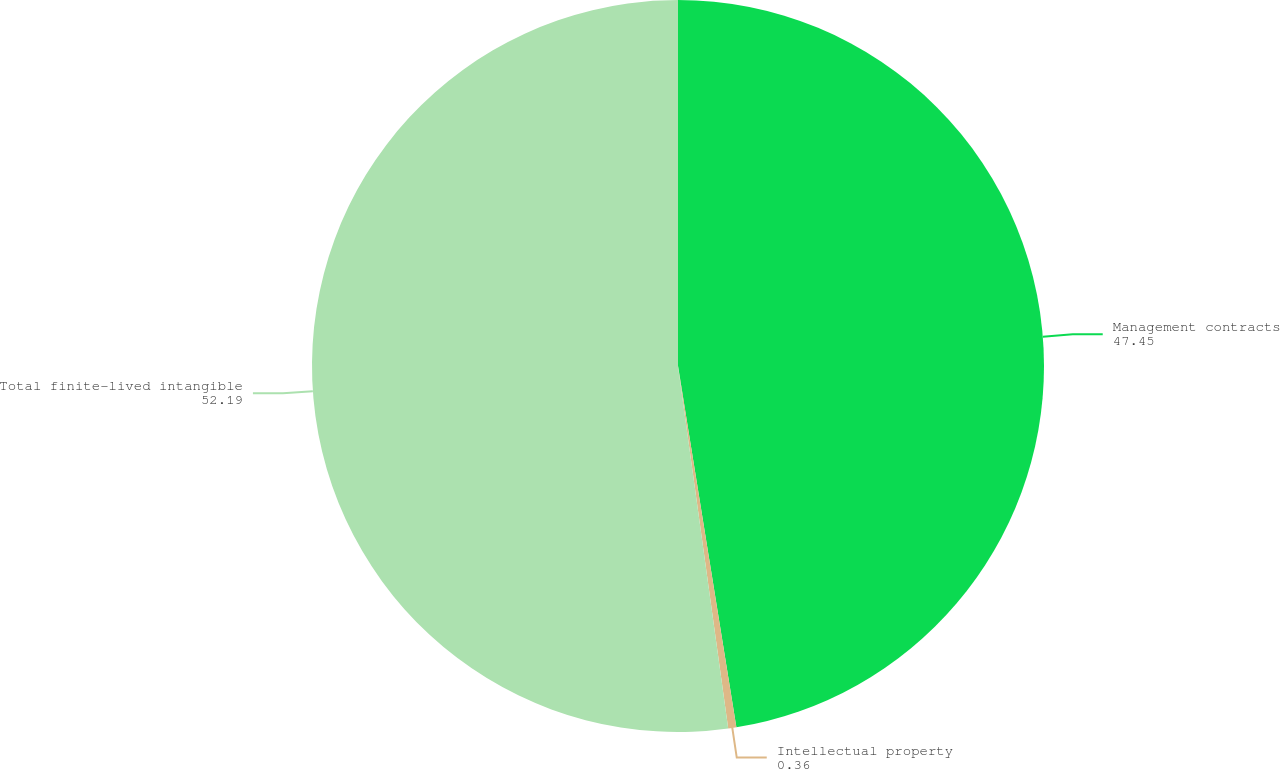<chart> <loc_0><loc_0><loc_500><loc_500><pie_chart><fcel>Management contracts<fcel>Intellectual property<fcel>Total finite-lived intangible<nl><fcel>47.45%<fcel>0.36%<fcel>52.19%<nl></chart> 